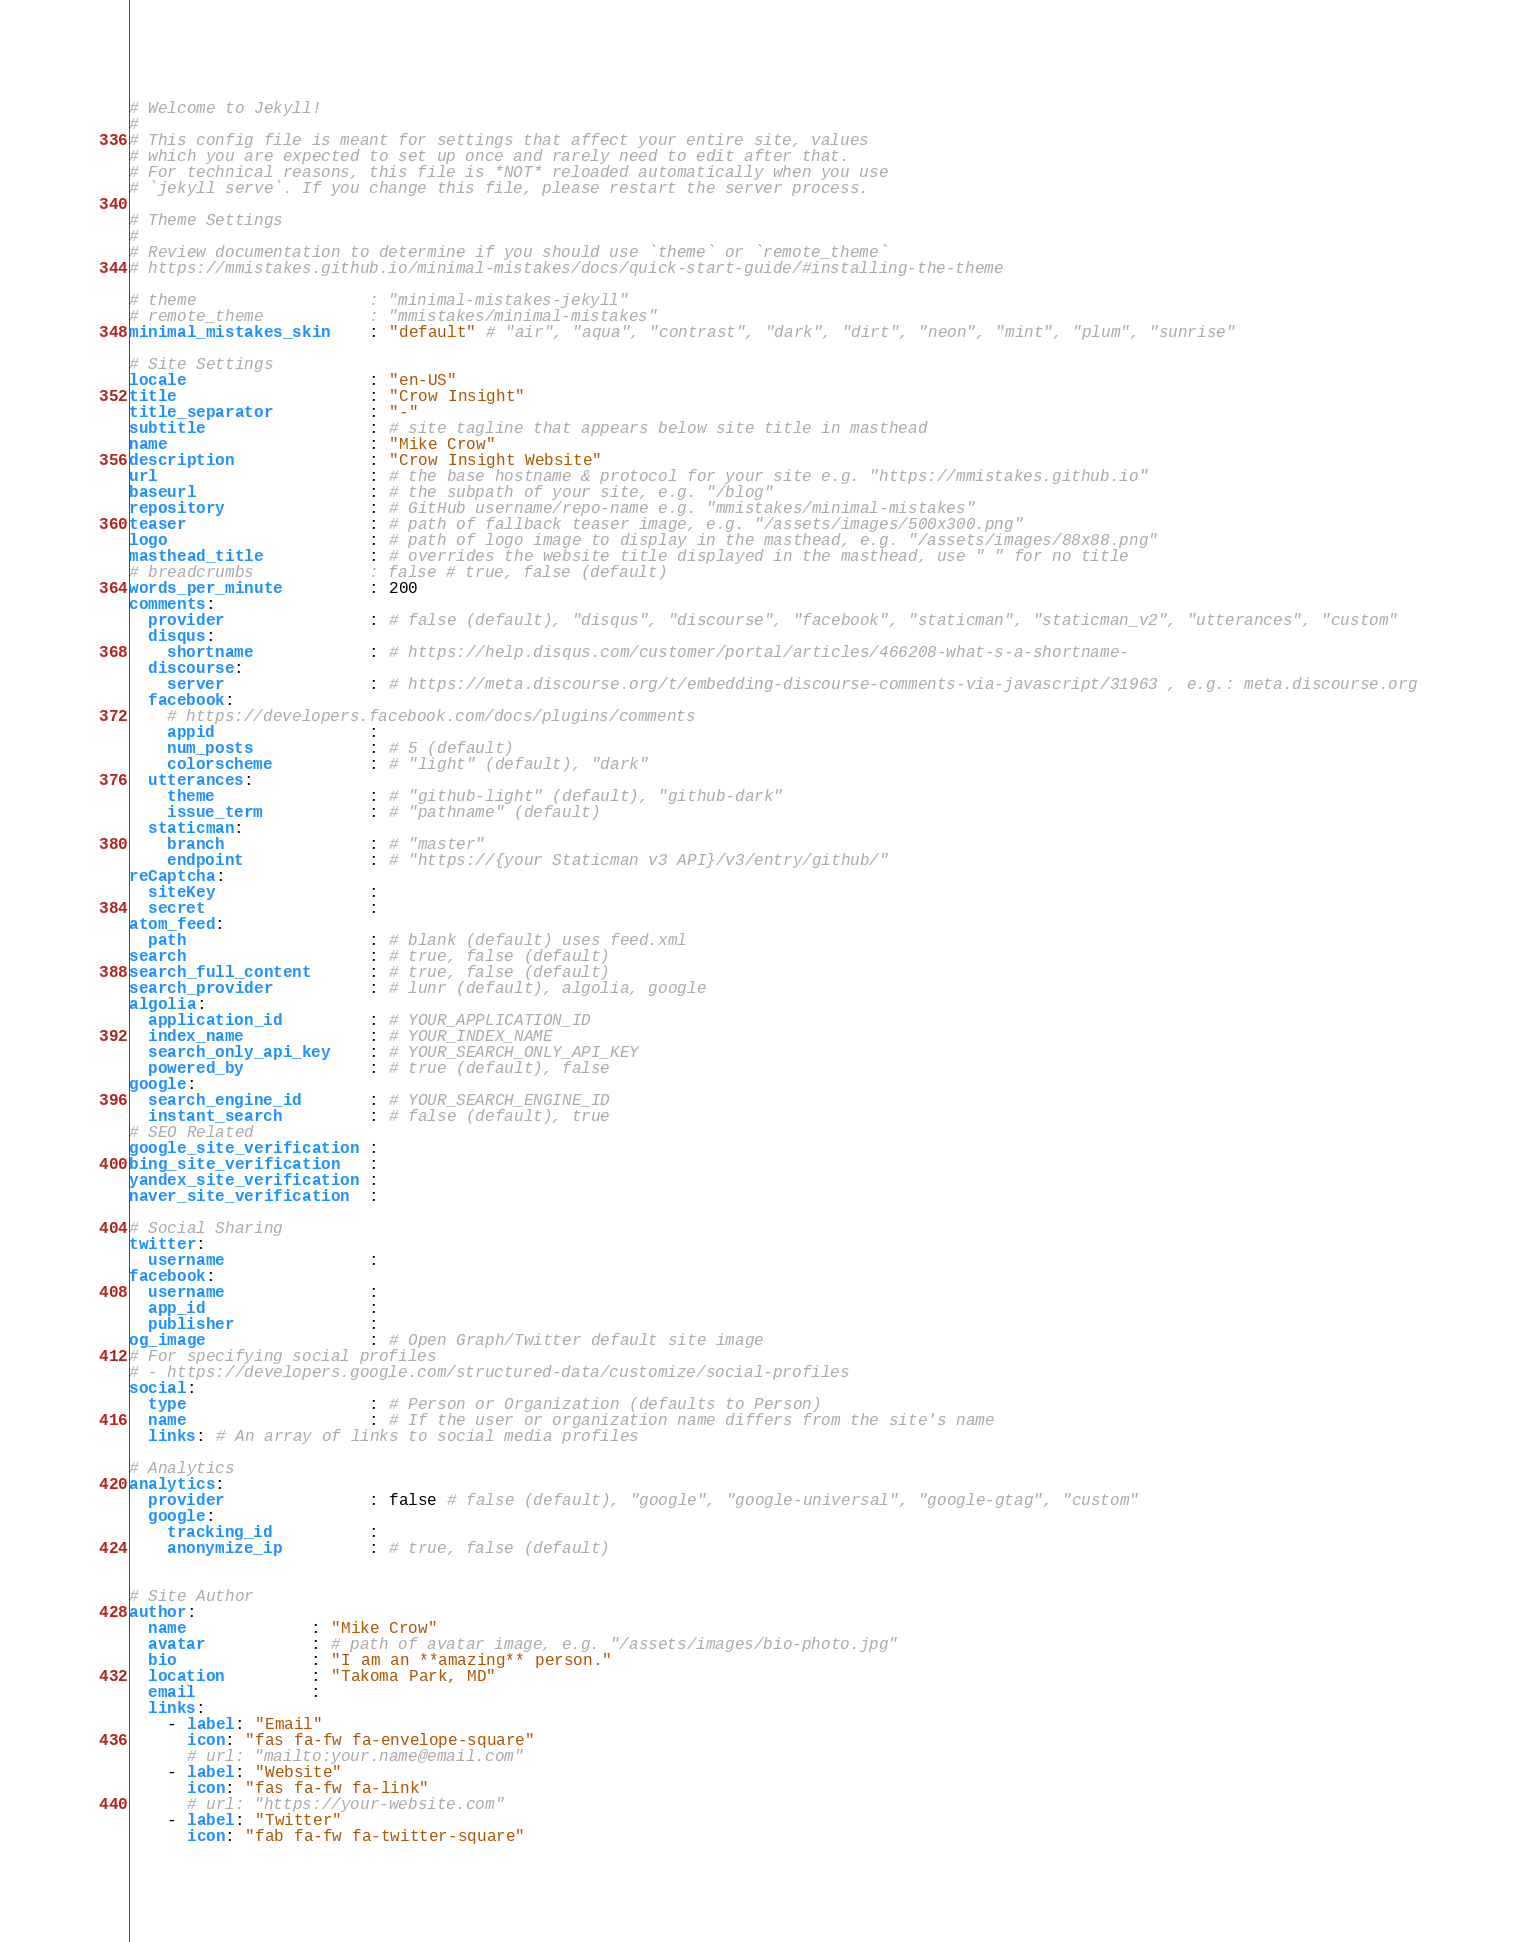<code> <loc_0><loc_0><loc_500><loc_500><_YAML_># Welcome to Jekyll!
#
# This config file is meant for settings that affect your entire site, values
# which you are expected to set up once and rarely need to edit after that.
# For technical reasons, this file is *NOT* reloaded automatically when you use
# `jekyll serve`. If you change this file, please restart the server process.

# Theme Settings
#
# Review documentation to determine if you should use `theme` or `remote_theme`
# https://mmistakes.github.io/minimal-mistakes/docs/quick-start-guide/#installing-the-theme

# theme                  : "minimal-mistakes-jekyll"
# remote_theme           : "mmistakes/minimal-mistakes"
minimal_mistakes_skin    : "default" # "air", "aqua", "contrast", "dark", "dirt", "neon", "mint", "plum", "sunrise"

# Site Settings
locale                   : "en-US"
title                    : "Crow Insight"
title_separator          : "-"
subtitle                 : # site tagline that appears below site title in masthead
name                     : "Mike Crow"
description              : "Crow Insight Website"
url                      : # the base hostname & protocol for your site e.g. "https://mmistakes.github.io"
baseurl                  : # the subpath of your site, e.g. "/blog"
repository               : # GitHub username/repo-name e.g. "mmistakes/minimal-mistakes"
teaser                   : # path of fallback teaser image, e.g. "/assets/images/500x300.png"
logo                     : # path of logo image to display in the masthead, e.g. "/assets/images/88x88.png"
masthead_title           : # overrides the website title displayed in the masthead, use " " for no title
# breadcrumbs            : false # true, false (default)
words_per_minute         : 200
comments:
  provider               : # false (default), "disqus", "discourse", "facebook", "staticman", "staticman_v2", "utterances", "custom"
  disqus:
    shortname            : # https://help.disqus.com/customer/portal/articles/466208-what-s-a-shortname-
  discourse:
    server               : # https://meta.discourse.org/t/embedding-discourse-comments-via-javascript/31963 , e.g.: meta.discourse.org
  facebook:
    # https://developers.facebook.com/docs/plugins/comments
    appid                :
    num_posts            : # 5 (default)
    colorscheme          : # "light" (default), "dark"
  utterances:
    theme                : # "github-light" (default), "github-dark"
    issue_term           : # "pathname" (default)
  staticman:
    branch               : # "master"
    endpoint             : # "https://{your Staticman v3 API}/v3/entry/github/"
reCaptcha:
  siteKey                :
  secret                 :
atom_feed:
  path                   : # blank (default) uses feed.xml
search                   : # true, false (default)
search_full_content      : # true, false (default)
search_provider          : # lunr (default), algolia, google
algolia:
  application_id         : # YOUR_APPLICATION_ID
  index_name             : # YOUR_INDEX_NAME
  search_only_api_key    : # YOUR_SEARCH_ONLY_API_KEY
  powered_by             : # true (default), false
google:
  search_engine_id       : # YOUR_SEARCH_ENGINE_ID
  instant_search         : # false (default), true
# SEO Related
google_site_verification :
bing_site_verification   :
yandex_site_verification :
naver_site_verification  :

# Social Sharing
twitter:
  username               :
facebook:
  username               :
  app_id                 :
  publisher              :
og_image                 : # Open Graph/Twitter default site image
# For specifying social profiles
# - https://developers.google.com/structured-data/customize/social-profiles
social:
  type                   : # Person or Organization (defaults to Person)
  name                   : # If the user or organization name differs from the site's name
  links: # An array of links to social media profiles

# Analytics
analytics:
  provider               : false # false (default), "google", "google-universal", "google-gtag", "custom"
  google:
    tracking_id          :
    anonymize_ip         : # true, false (default)


# Site Author
author:
  name             : "Mike Crow"
  avatar           : # path of avatar image, e.g. "/assets/images/bio-photo.jpg"
  bio              : "I am an **amazing** person."
  location         : "Takoma Park, MD"
  email            :
  links:
    - label: "Email"
      icon: "fas fa-fw fa-envelope-square"
      # url: "mailto:your.name@email.com"
    - label: "Website"
      icon: "fas fa-fw fa-link"
      # url: "https://your-website.com"
    - label: "Twitter"
      icon: "fab fa-fw fa-twitter-square"</code> 